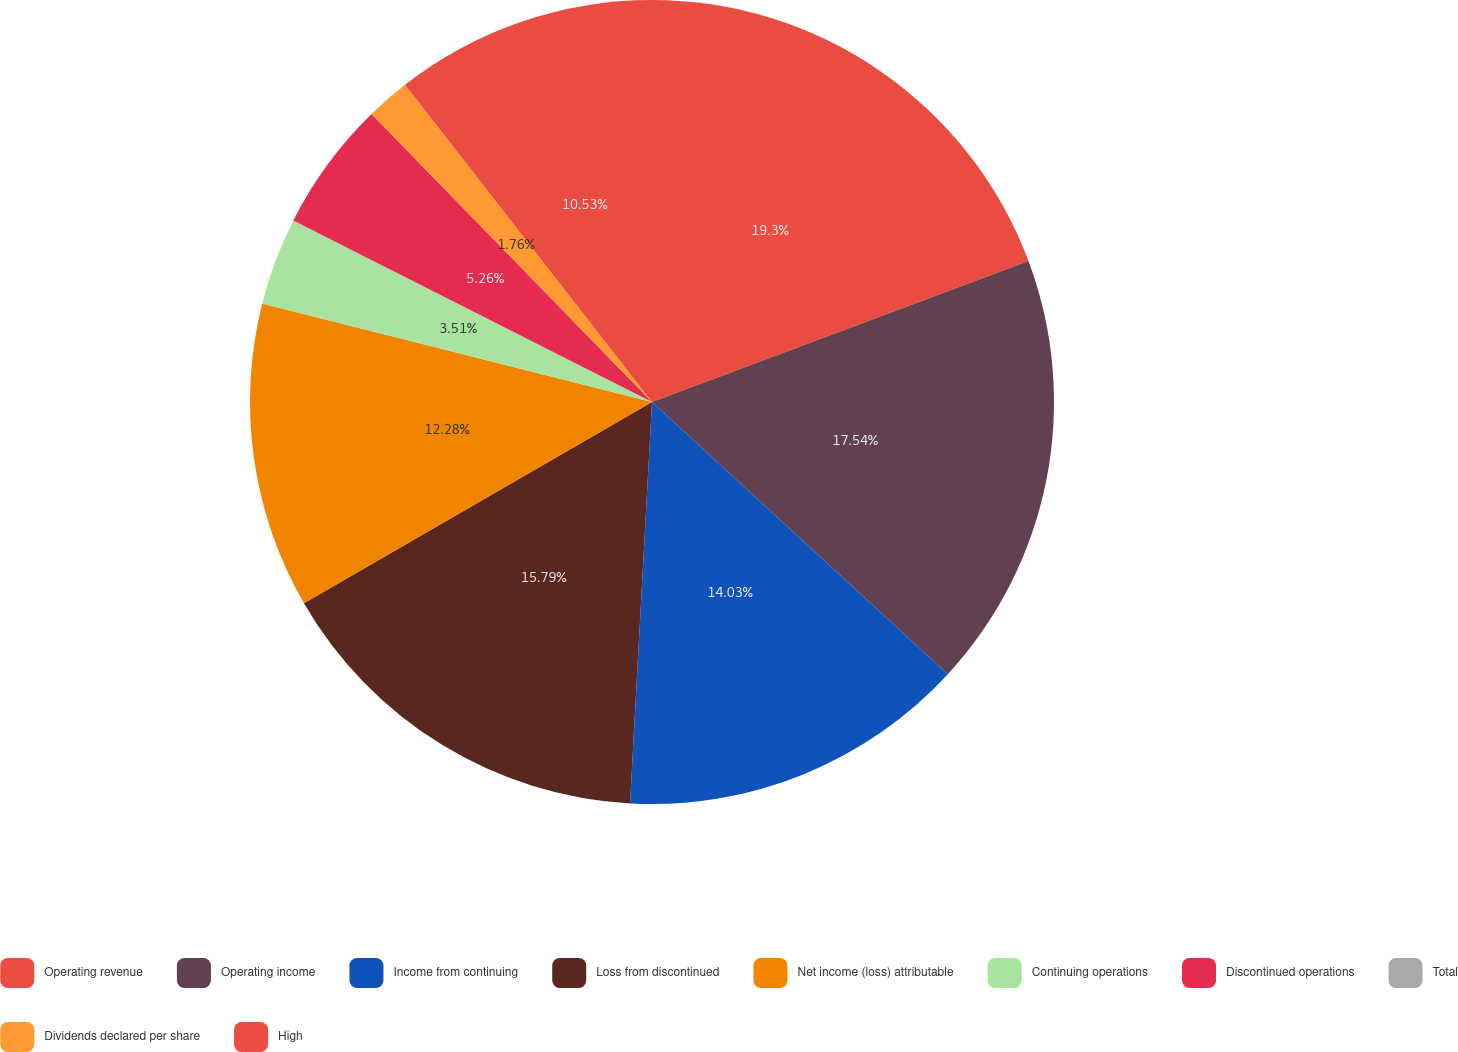Convert chart. <chart><loc_0><loc_0><loc_500><loc_500><pie_chart><fcel>Operating revenue<fcel>Operating income<fcel>Income from continuing<fcel>Loss from discontinued<fcel>Net income (loss) attributable<fcel>Continuing operations<fcel>Discontinued operations<fcel>Total<fcel>Dividends declared per share<fcel>High<nl><fcel>19.3%<fcel>17.54%<fcel>14.03%<fcel>15.79%<fcel>12.28%<fcel>3.51%<fcel>5.26%<fcel>0.0%<fcel>1.76%<fcel>10.53%<nl></chart> 